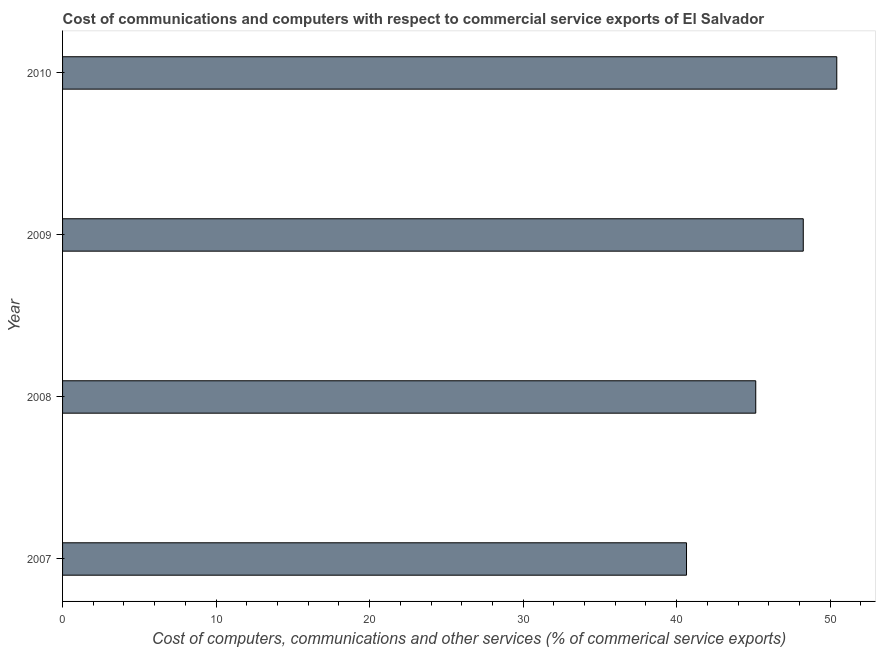Does the graph contain any zero values?
Your response must be concise. No. What is the title of the graph?
Offer a terse response. Cost of communications and computers with respect to commercial service exports of El Salvador. What is the label or title of the X-axis?
Offer a very short reply. Cost of computers, communications and other services (% of commerical service exports). What is the cost of communications in 2008?
Ensure brevity in your answer.  45.15. Across all years, what is the maximum  computer and other services?
Provide a succinct answer. 50.43. Across all years, what is the minimum cost of communications?
Provide a short and direct response. 40.64. What is the sum of the cost of communications?
Keep it short and to the point. 184.46. What is the difference between the cost of communications in 2008 and 2010?
Ensure brevity in your answer.  -5.28. What is the average  computer and other services per year?
Give a very brief answer. 46.12. What is the median  computer and other services?
Ensure brevity in your answer.  46.7. What is the ratio of the cost of communications in 2009 to that in 2010?
Ensure brevity in your answer.  0.96. Is the cost of communications in 2007 less than that in 2008?
Offer a terse response. Yes. What is the difference between the highest and the second highest cost of communications?
Give a very brief answer. 2.18. Is the sum of the  computer and other services in 2009 and 2010 greater than the maximum  computer and other services across all years?
Ensure brevity in your answer.  Yes. What is the difference between the highest and the lowest  computer and other services?
Make the answer very short. 9.79. In how many years, is the  computer and other services greater than the average  computer and other services taken over all years?
Offer a very short reply. 2. Are all the bars in the graph horizontal?
Keep it short and to the point. Yes. Are the values on the major ticks of X-axis written in scientific E-notation?
Offer a very short reply. No. What is the Cost of computers, communications and other services (% of commerical service exports) of 2007?
Make the answer very short. 40.64. What is the Cost of computers, communications and other services (% of commerical service exports) in 2008?
Offer a terse response. 45.15. What is the Cost of computers, communications and other services (% of commerical service exports) of 2009?
Provide a short and direct response. 48.24. What is the Cost of computers, communications and other services (% of commerical service exports) of 2010?
Provide a succinct answer. 50.43. What is the difference between the Cost of computers, communications and other services (% of commerical service exports) in 2007 and 2008?
Make the answer very short. -4.51. What is the difference between the Cost of computers, communications and other services (% of commerical service exports) in 2007 and 2009?
Provide a succinct answer. -7.6. What is the difference between the Cost of computers, communications and other services (% of commerical service exports) in 2007 and 2010?
Make the answer very short. -9.79. What is the difference between the Cost of computers, communications and other services (% of commerical service exports) in 2008 and 2009?
Make the answer very short. -3.09. What is the difference between the Cost of computers, communications and other services (% of commerical service exports) in 2008 and 2010?
Provide a succinct answer. -5.28. What is the difference between the Cost of computers, communications and other services (% of commerical service exports) in 2009 and 2010?
Provide a short and direct response. -2.18. What is the ratio of the Cost of computers, communications and other services (% of commerical service exports) in 2007 to that in 2008?
Provide a succinct answer. 0.9. What is the ratio of the Cost of computers, communications and other services (% of commerical service exports) in 2007 to that in 2009?
Your answer should be very brief. 0.84. What is the ratio of the Cost of computers, communications and other services (% of commerical service exports) in 2007 to that in 2010?
Offer a very short reply. 0.81. What is the ratio of the Cost of computers, communications and other services (% of commerical service exports) in 2008 to that in 2009?
Keep it short and to the point. 0.94. What is the ratio of the Cost of computers, communications and other services (% of commerical service exports) in 2008 to that in 2010?
Provide a succinct answer. 0.9. What is the ratio of the Cost of computers, communications and other services (% of commerical service exports) in 2009 to that in 2010?
Provide a succinct answer. 0.96. 